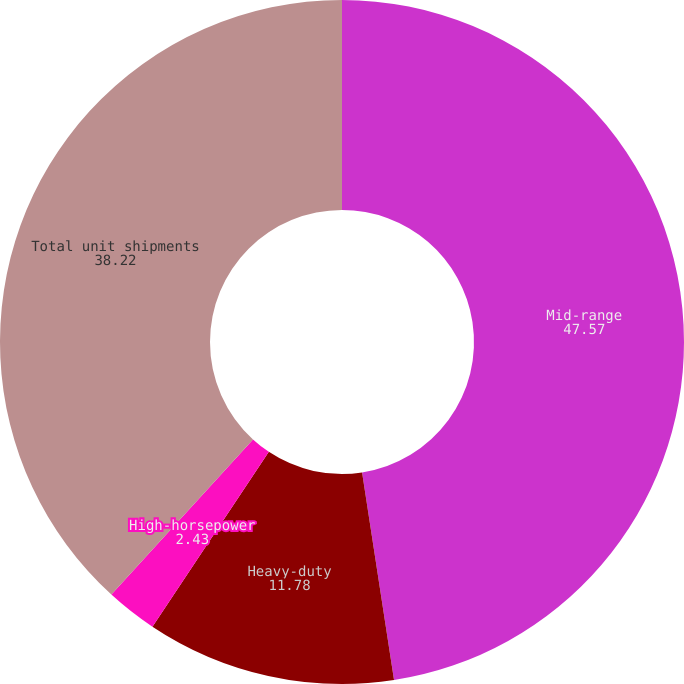Convert chart. <chart><loc_0><loc_0><loc_500><loc_500><pie_chart><fcel>Mid-range<fcel>Heavy-duty<fcel>High-horsepower<fcel>Total unit shipments<nl><fcel>47.57%<fcel>11.78%<fcel>2.43%<fcel>38.22%<nl></chart> 